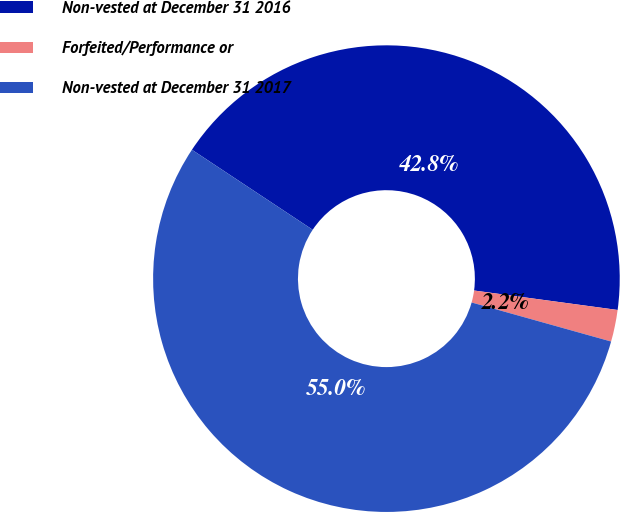Convert chart. <chart><loc_0><loc_0><loc_500><loc_500><pie_chart><fcel>Non-vested at December 31 2016<fcel>Forfeited/Performance or<fcel>Non-vested at December 31 2017<nl><fcel>42.83%<fcel>2.2%<fcel>54.97%<nl></chart> 